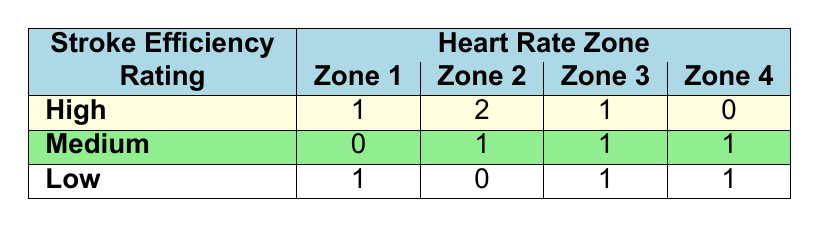What's the total number of swimmers in the high stroke efficiency rating category? There is one swimmer in Zone 1, two swimmers in Zone 2, one swimmer in Zone 3, and none in Zone 4. The total number of swimmers is 1 + 2 + 1 + 0 = 4.
Answer: 4 How many swimmers have a stroke efficiency rating of medium in Zone 4? There is one swimmer with a medium stroke efficiency rating listed in Zone 4.
Answer: 1 Which heart rate zone has the highest number of swimmers with low stroke efficiency? Zone 4 has two swimmers with low stroke efficiency (Charlie Brown and Fiona Apple), which is more than any other zone.
Answer: Zone 4 What is the difference in the number of high efficiency swimmers between Zone 1 and Zone 3? There is one high efficiency swimmer in Zone 1 and one in Zone 3. The difference is 1 - 1 = 0.
Answer: 0 Is there at least one swimmer in Zone 2 with high stroke efficiency? Yes, there are two swimmers categorized as having high stroke efficiency in Zone 2.
Answer: Yes How many total swimmers are there in Zone 2? Adding the swimmers by stroke efficiency in Zone 2, we have 2 (high) + 1 (medium) + 0 (low) = 3 swimmers total.
Answer: 3 Which heart rate zone has the fewest number of swimmers overall? At a glance, Zone 4 only has 2 swimmers (one with low efficiency and one with medium efficiency), making it the zone with the fewest swimmers.
Answer: Zone 4 How many swimmers with a stroke efficiency rating of medium are there in total compared to those with low efficiency? There is a sum of 3 swimmers with medium efficiency (1 in Zone 2, 1 in Zone 3, 1 in Zone 4) compared to 3 swimmers with low efficiency (1 in Zone 1, 1 in Zone 3, 1 in Zone 4). Hence they are equal, with a total of 3 each.
Answer: Equal (3 each) Is it true that there are no swimmers with high stroke efficiency in Zone 4? Yes, according to the table, there are no swimmers listed with high stroke efficiency in Zone 4.
Answer: Yes 